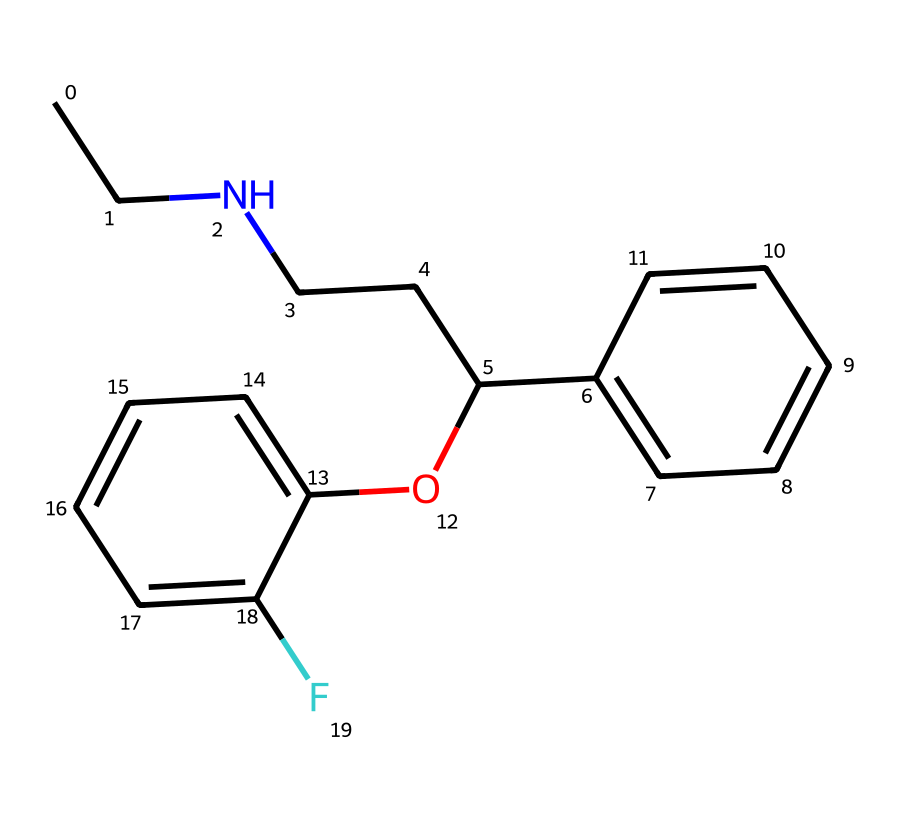What is the name of this chemical? This chemical corresponds to fluoxetine, commonly known as Prozac, which is indicated as an antidepressant. The structure and the presence of specific functional groups, particularly the fluorine atom and the amine, confirm its identity.
Answer: fluoxetine How many carbon atoms are present in the structure? By counting the carbon atoms in the SMILES representation, there are 17 carbon atoms present. Each 'C' in the SMILES denotes a carbon atom, and their connections are deduced from the structure's connectivity.
Answer: 17 What type of functional group is present in this drug? The structure contains an amine group (indicated by the nitrogen atom connected to carbon), which is characteristic of many antidepressant medications, thereby classifying it accordingly.
Answer: amine What is the molecular formula of fluoxetine? To deduce the molecular formula from the SMILES, the composition of each atom is counted: 17 carbon (C), 18 hydrogen (H), 1 nitrogen (N), and 1 fluorine (F), leading to the formula C17H18F1N1.
Answer: C17H18FN How many rings are in the molecular structure? The chemical structure features two aromatic rings, as indicated by the cyclic nature of the benzene-like structures in the SMILES. Each cycle is seen with alternating double bonds in the notation.
Answer: 2 What type of chemical is fluoxetine classified as? Fluoxetine is classified as a selective serotonin reuptake inhibitor (SSRI), a common type of antidepressant that is used to treat depression and anxiety disorders.
Answer: SSRI What is the role of the fluorine atom in fluoxetine? The fluorine atom in fluoxetine enhances the lipophilicity of the molecule, which significantly contributes to its efficacy and bioavailability as an antidepressant.
Answer: lipophilicity 